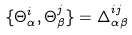Convert formula to latex. <formula><loc_0><loc_0><loc_500><loc_500>\{ \Theta ^ { i } _ { \alpha } , \Theta ^ { j } _ { \beta } \} = \Delta ^ { i j } _ { \alpha \beta }</formula> 